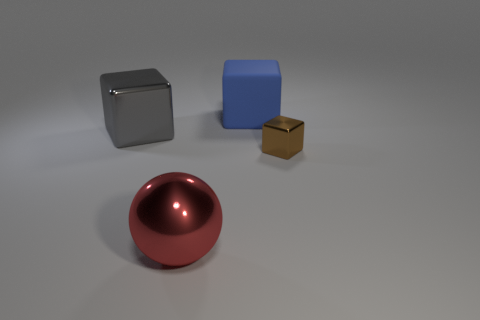Add 2 brown spheres. How many objects exist? 6 Subtract all balls. How many objects are left? 3 Add 4 tiny cyan rubber balls. How many tiny cyan rubber balls exist? 4 Subtract 0 yellow cylinders. How many objects are left? 4 Subtract all tiny shiny things. Subtract all brown cubes. How many objects are left? 2 Add 3 shiny things. How many shiny things are left? 6 